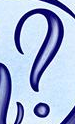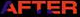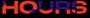Transcribe the words shown in these images in order, separated by a semicolon. ?; AFTER; HOURS 